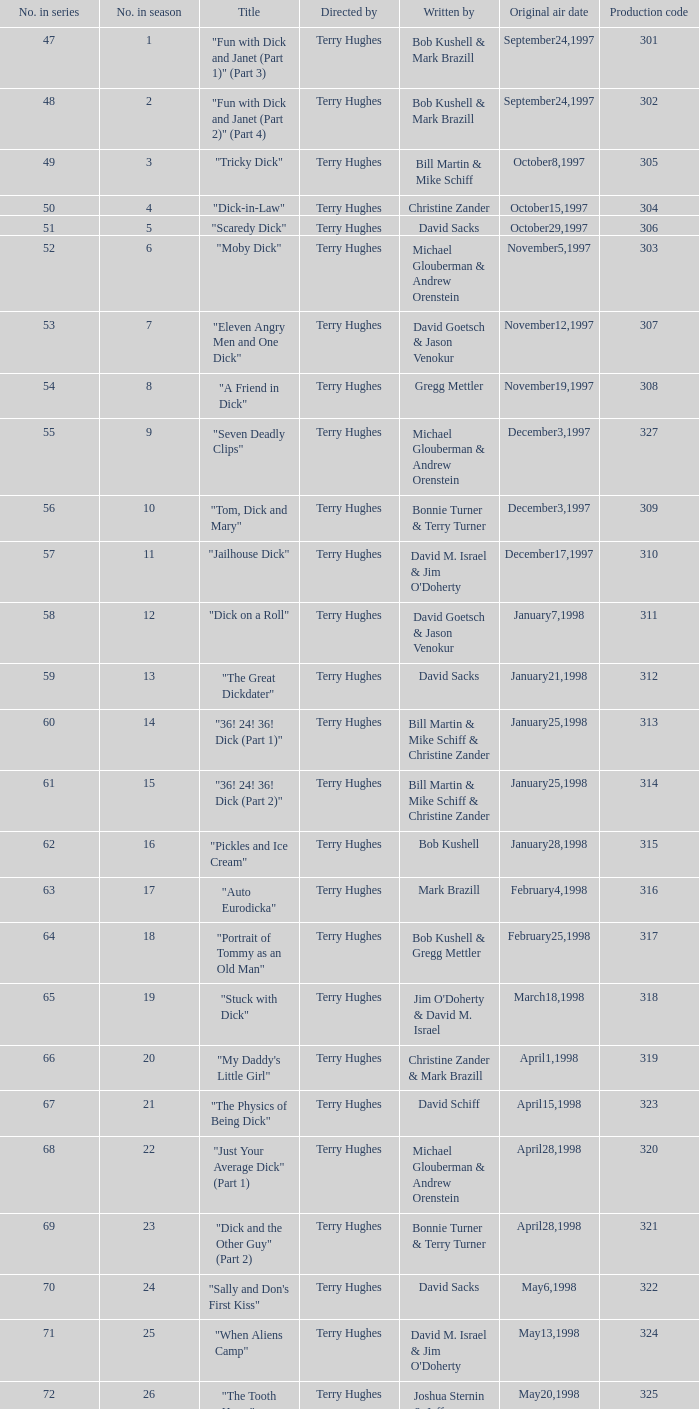What is the original air date of the episode with production code is 319? April1,1998. 